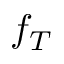<formula> <loc_0><loc_0><loc_500><loc_500>f _ { T }</formula> 